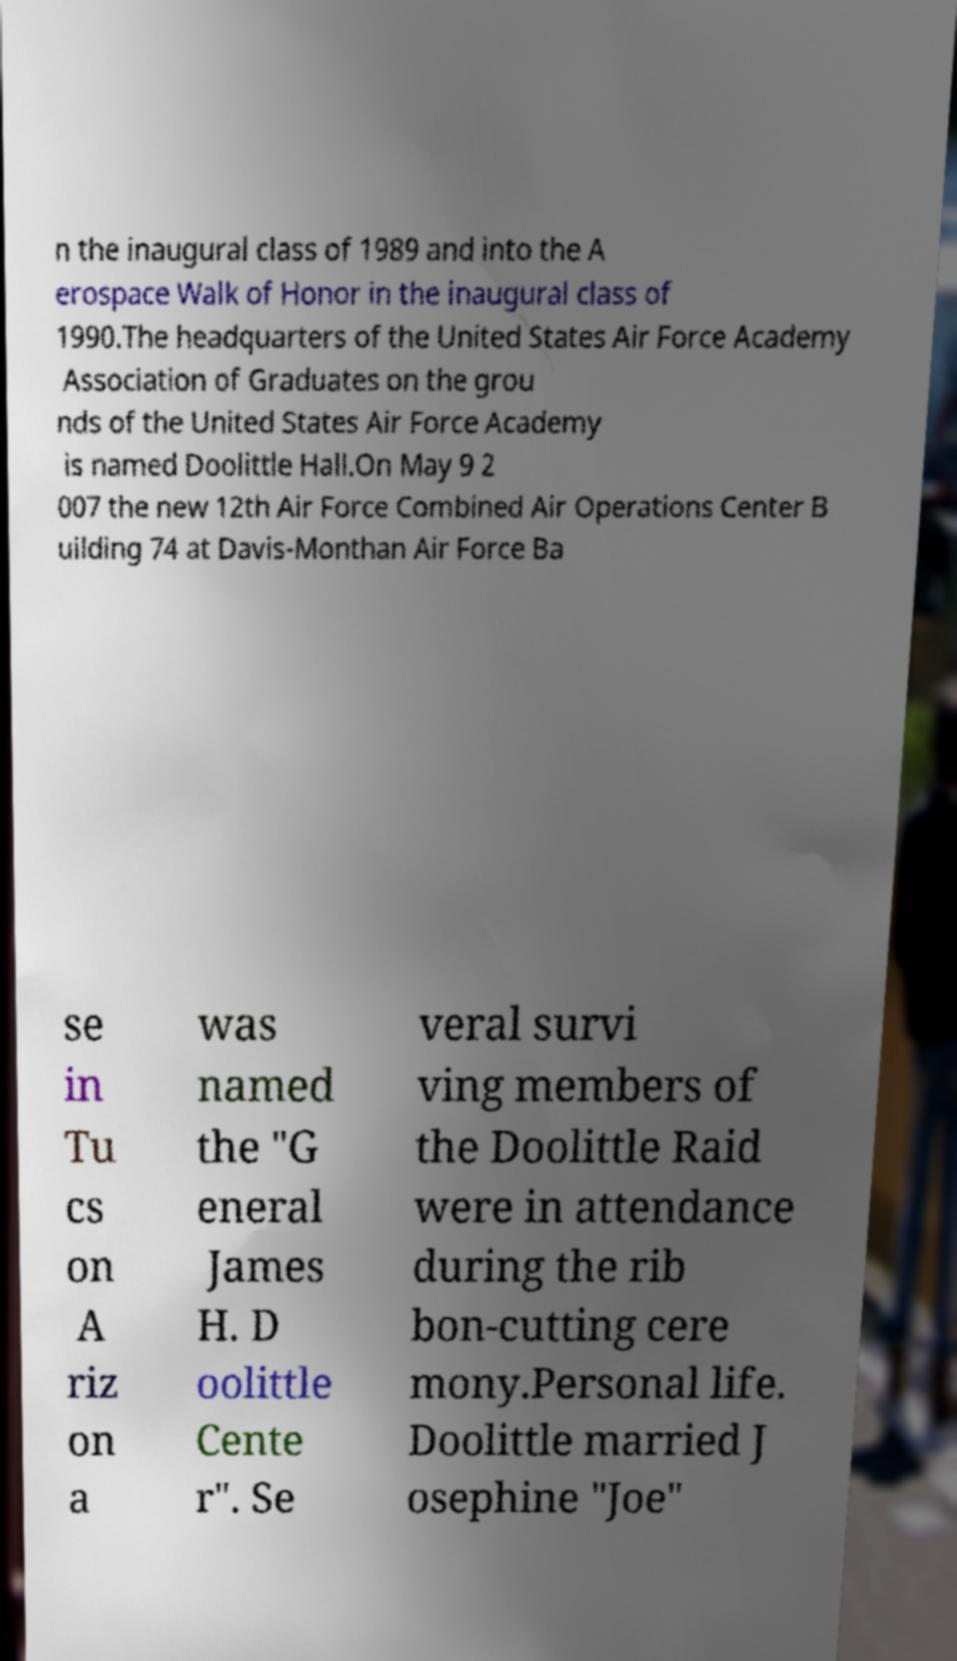Can you read and provide the text displayed in the image?This photo seems to have some interesting text. Can you extract and type it out for me? n the inaugural class of 1989 and into the A erospace Walk of Honor in the inaugural class of 1990.The headquarters of the United States Air Force Academy Association of Graduates on the grou nds of the United States Air Force Academy is named Doolittle Hall.On May 9 2 007 the new 12th Air Force Combined Air Operations Center B uilding 74 at Davis-Monthan Air Force Ba se in Tu cs on A riz on a was named the "G eneral James H. D oolittle Cente r". Se veral survi ving members of the Doolittle Raid were in attendance during the rib bon-cutting cere mony.Personal life. Doolittle married J osephine "Joe" 